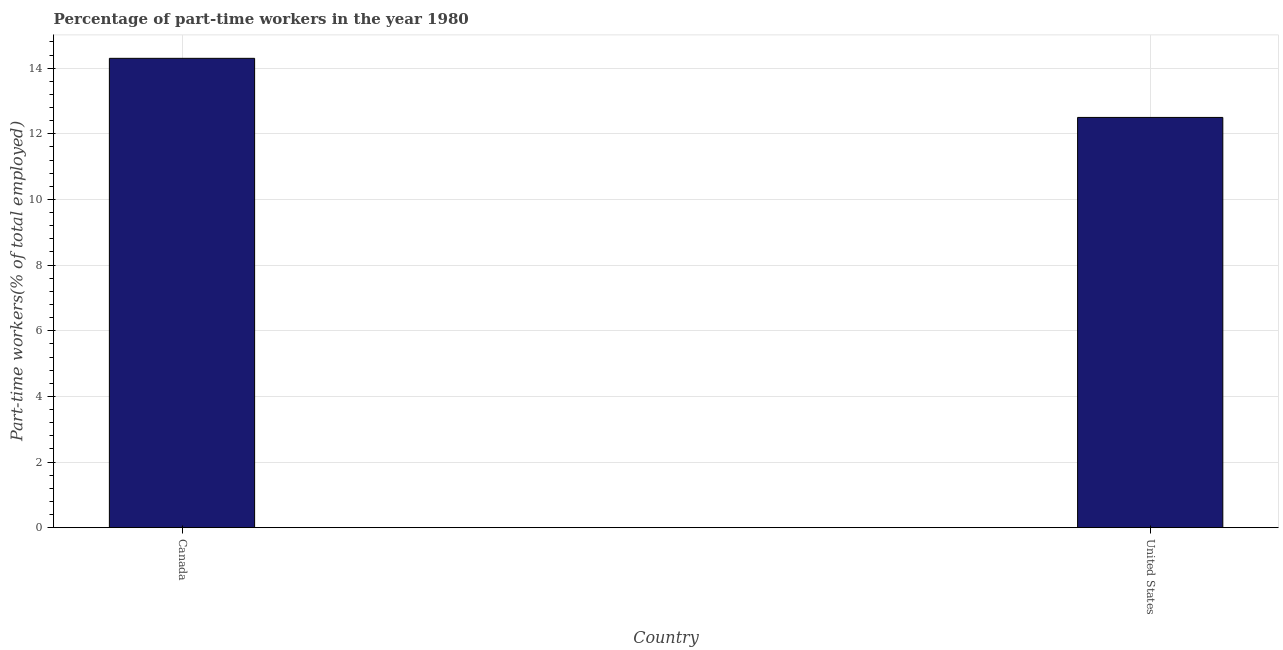Does the graph contain any zero values?
Give a very brief answer. No. Does the graph contain grids?
Make the answer very short. Yes. What is the title of the graph?
Provide a short and direct response. Percentage of part-time workers in the year 1980. What is the label or title of the Y-axis?
Provide a succinct answer. Part-time workers(% of total employed). What is the percentage of part-time workers in United States?
Give a very brief answer. 12.5. Across all countries, what is the maximum percentage of part-time workers?
Provide a short and direct response. 14.3. Across all countries, what is the minimum percentage of part-time workers?
Make the answer very short. 12.5. What is the sum of the percentage of part-time workers?
Offer a terse response. 26.8. What is the difference between the percentage of part-time workers in Canada and United States?
Provide a succinct answer. 1.8. What is the median percentage of part-time workers?
Offer a very short reply. 13.4. In how many countries, is the percentage of part-time workers greater than 10.4 %?
Your response must be concise. 2. What is the ratio of the percentage of part-time workers in Canada to that in United States?
Keep it short and to the point. 1.14. Is the percentage of part-time workers in Canada less than that in United States?
Keep it short and to the point. No. Are the values on the major ticks of Y-axis written in scientific E-notation?
Ensure brevity in your answer.  No. What is the Part-time workers(% of total employed) of Canada?
Offer a very short reply. 14.3. What is the Part-time workers(% of total employed) in United States?
Provide a succinct answer. 12.5. What is the difference between the Part-time workers(% of total employed) in Canada and United States?
Ensure brevity in your answer.  1.8. What is the ratio of the Part-time workers(% of total employed) in Canada to that in United States?
Ensure brevity in your answer.  1.14. 